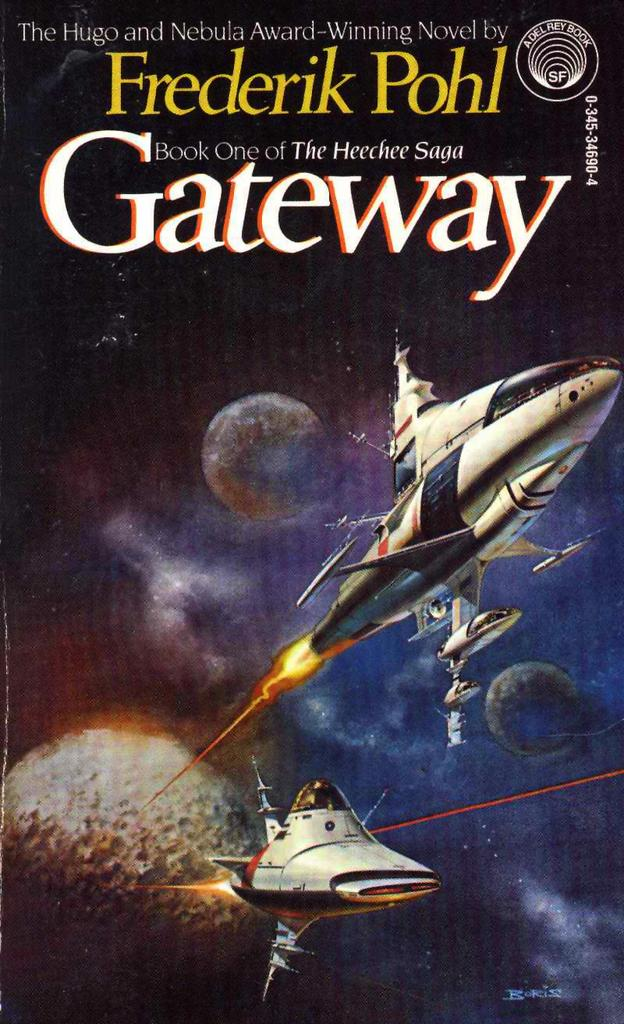What is featured on the poster in the image? The poster contains images of choppers and a plane. Where is the text located on the poster? The text is at the top of the poster. What type of property is visible in the background of the image? There is no property visible in the image; it only features a poster with images of choppers and a plane. 